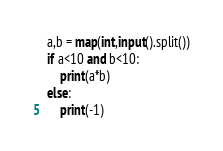<code> <loc_0><loc_0><loc_500><loc_500><_Python_>
a,b = map(int,input().split())
if a<10 and b<10:
    print(a*b)
else:
    print(-1)
</code> 